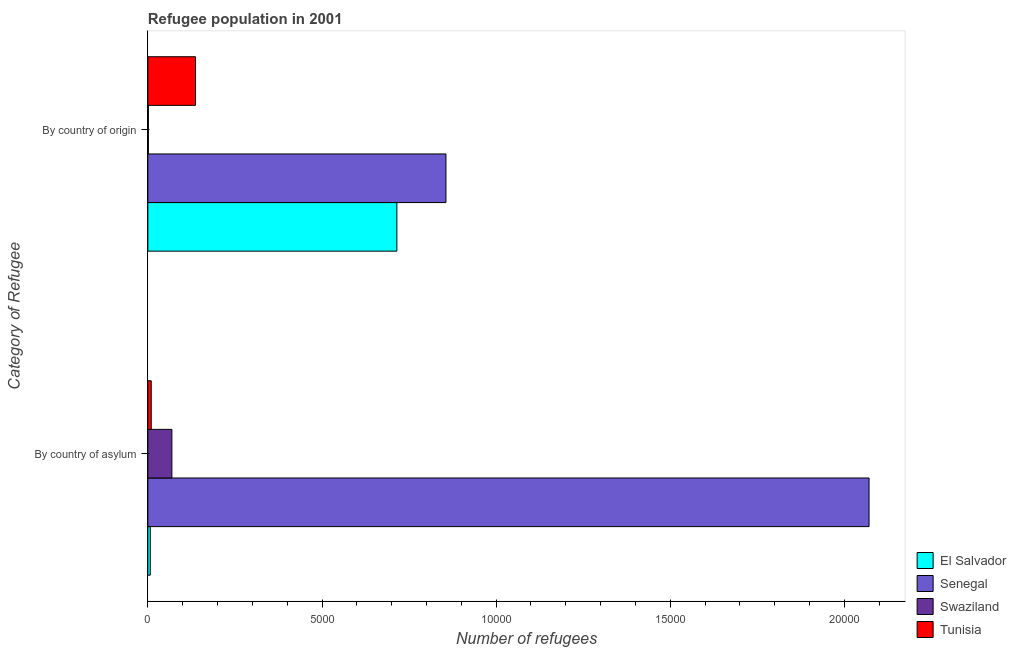How many different coloured bars are there?
Give a very brief answer. 4. Are the number of bars per tick equal to the number of legend labels?
Provide a short and direct response. Yes. Are the number of bars on each tick of the Y-axis equal?
Ensure brevity in your answer.  Yes. How many bars are there on the 1st tick from the bottom?
Provide a succinct answer. 4. What is the label of the 2nd group of bars from the top?
Your response must be concise. By country of asylum. What is the number of refugees by country of origin in El Salvador?
Keep it short and to the point. 7150. Across all countries, what is the maximum number of refugees by country of asylum?
Your answer should be compact. 2.07e+04. Across all countries, what is the minimum number of refugees by country of origin?
Your response must be concise. 15. In which country was the number of refugees by country of asylum maximum?
Your response must be concise. Senegal. In which country was the number of refugees by country of asylum minimum?
Your answer should be very brief. El Salvador. What is the total number of refugees by country of asylum in the graph?
Your answer should be very brief. 2.16e+04. What is the difference between the number of refugees by country of origin in El Salvador and that in Senegal?
Provide a succinct answer. -1409. What is the difference between the number of refugees by country of origin in El Salvador and the number of refugees by country of asylum in Senegal?
Provide a succinct answer. -1.36e+04. What is the average number of refugees by country of asylum per country?
Ensure brevity in your answer.  5390.75. What is the difference between the number of refugees by country of origin and number of refugees by country of asylum in El Salvador?
Offer a very short reply. 7081. What is the ratio of the number of refugees by country of asylum in Swaziland to that in Senegal?
Ensure brevity in your answer.  0.03. Is the number of refugees by country of asylum in El Salvador less than that in Senegal?
Make the answer very short. Yes. In how many countries, is the number of refugees by country of origin greater than the average number of refugees by country of origin taken over all countries?
Provide a short and direct response. 2. What does the 3rd bar from the top in By country of asylum represents?
Provide a succinct answer. Senegal. What does the 1st bar from the bottom in By country of asylum represents?
Provide a succinct answer. El Salvador. Are all the bars in the graph horizontal?
Ensure brevity in your answer.  Yes. What is the difference between two consecutive major ticks on the X-axis?
Offer a very short reply. 5000. Does the graph contain any zero values?
Your answer should be very brief. No. Where does the legend appear in the graph?
Your response must be concise. Bottom right. How many legend labels are there?
Give a very brief answer. 4. How are the legend labels stacked?
Give a very brief answer. Vertical. What is the title of the graph?
Ensure brevity in your answer.  Refugee population in 2001. Does "OECD members" appear as one of the legend labels in the graph?
Offer a very short reply. No. What is the label or title of the X-axis?
Provide a succinct answer. Number of refugees. What is the label or title of the Y-axis?
Give a very brief answer. Category of Refugee. What is the Number of refugees of Senegal in By country of asylum?
Offer a very short reply. 2.07e+04. What is the Number of refugees in Swaziland in By country of asylum?
Offer a very short reply. 690. What is the Number of refugees in Tunisia in By country of asylum?
Your answer should be very brief. 97. What is the Number of refugees in El Salvador in By country of origin?
Offer a very short reply. 7150. What is the Number of refugees in Senegal in By country of origin?
Your response must be concise. 8559. What is the Number of refugees of Tunisia in By country of origin?
Provide a short and direct response. 1368. Across all Category of Refugee, what is the maximum Number of refugees of El Salvador?
Offer a very short reply. 7150. Across all Category of Refugee, what is the maximum Number of refugees of Senegal?
Offer a very short reply. 2.07e+04. Across all Category of Refugee, what is the maximum Number of refugees in Swaziland?
Provide a short and direct response. 690. Across all Category of Refugee, what is the maximum Number of refugees of Tunisia?
Provide a succinct answer. 1368. Across all Category of Refugee, what is the minimum Number of refugees in El Salvador?
Your answer should be very brief. 69. Across all Category of Refugee, what is the minimum Number of refugees of Senegal?
Offer a very short reply. 8559. Across all Category of Refugee, what is the minimum Number of refugees in Tunisia?
Your answer should be very brief. 97. What is the total Number of refugees in El Salvador in the graph?
Ensure brevity in your answer.  7219. What is the total Number of refugees of Senegal in the graph?
Your answer should be compact. 2.93e+04. What is the total Number of refugees of Swaziland in the graph?
Ensure brevity in your answer.  705. What is the total Number of refugees of Tunisia in the graph?
Your response must be concise. 1465. What is the difference between the Number of refugees in El Salvador in By country of asylum and that in By country of origin?
Offer a terse response. -7081. What is the difference between the Number of refugees in Senegal in By country of asylum and that in By country of origin?
Make the answer very short. 1.21e+04. What is the difference between the Number of refugees of Swaziland in By country of asylum and that in By country of origin?
Your answer should be compact. 675. What is the difference between the Number of refugees in Tunisia in By country of asylum and that in By country of origin?
Provide a succinct answer. -1271. What is the difference between the Number of refugees of El Salvador in By country of asylum and the Number of refugees of Senegal in By country of origin?
Provide a short and direct response. -8490. What is the difference between the Number of refugees of El Salvador in By country of asylum and the Number of refugees of Swaziland in By country of origin?
Provide a short and direct response. 54. What is the difference between the Number of refugees of El Salvador in By country of asylum and the Number of refugees of Tunisia in By country of origin?
Keep it short and to the point. -1299. What is the difference between the Number of refugees in Senegal in By country of asylum and the Number of refugees in Swaziland in By country of origin?
Your answer should be very brief. 2.07e+04. What is the difference between the Number of refugees of Senegal in By country of asylum and the Number of refugees of Tunisia in By country of origin?
Provide a succinct answer. 1.93e+04. What is the difference between the Number of refugees in Swaziland in By country of asylum and the Number of refugees in Tunisia in By country of origin?
Ensure brevity in your answer.  -678. What is the average Number of refugees in El Salvador per Category of Refugee?
Offer a very short reply. 3609.5. What is the average Number of refugees in Senegal per Category of Refugee?
Make the answer very short. 1.46e+04. What is the average Number of refugees in Swaziland per Category of Refugee?
Offer a terse response. 352.5. What is the average Number of refugees in Tunisia per Category of Refugee?
Your answer should be very brief. 732.5. What is the difference between the Number of refugees in El Salvador and Number of refugees in Senegal in By country of asylum?
Give a very brief answer. -2.06e+04. What is the difference between the Number of refugees in El Salvador and Number of refugees in Swaziland in By country of asylum?
Your answer should be very brief. -621. What is the difference between the Number of refugees of Senegal and Number of refugees of Swaziland in By country of asylum?
Offer a terse response. 2.00e+04. What is the difference between the Number of refugees in Senegal and Number of refugees in Tunisia in By country of asylum?
Your answer should be compact. 2.06e+04. What is the difference between the Number of refugees of Swaziland and Number of refugees of Tunisia in By country of asylum?
Give a very brief answer. 593. What is the difference between the Number of refugees of El Salvador and Number of refugees of Senegal in By country of origin?
Your response must be concise. -1409. What is the difference between the Number of refugees in El Salvador and Number of refugees in Swaziland in By country of origin?
Give a very brief answer. 7135. What is the difference between the Number of refugees of El Salvador and Number of refugees of Tunisia in By country of origin?
Your answer should be compact. 5782. What is the difference between the Number of refugees of Senegal and Number of refugees of Swaziland in By country of origin?
Your answer should be compact. 8544. What is the difference between the Number of refugees in Senegal and Number of refugees in Tunisia in By country of origin?
Offer a very short reply. 7191. What is the difference between the Number of refugees of Swaziland and Number of refugees of Tunisia in By country of origin?
Keep it short and to the point. -1353. What is the ratio of the Number of refugees in El Salvador in By country of asylum to that in By country of origin?
Make the answer very short. 0.01. What is the ratio of the Number of refugees of Senegal in By country of asylum to that in By country of origin?
Your answer should be compact. 2.42. What is the ratio of the Number of refugees of Swaziland in By country of asylum to that in By country of origin?
Provide a succinct answer. 46. What is the ratio of the Number of refugees in Tunisia in By country of asylum to that in By country of origin?
Keep it short and to the point. 0.07. What is the difference between the highest and the second highest Number of refugees in El Salvador?
Offer a terse response. 7081. What is the difference between the highest and the second highest Number of refugees in Senegal?
Your answer should be very brief. 1.21e+04. What is the difference between the highest and the second highest Number of refugees in Swaziland?
Keep it short and to the point. 675. What is the difference between the highest and the second highest Number of refugees in Tunisia?
Your answer should be compact. 1271. What is the difference between the highest and the lowest Number of refugees of El Salvador?
Make the answer very short. 7081. What is the difference between the highest and the lowest Number of refugees of Senegal?
Your answer should be compact. 1.21e+04. What is the difference between the highest and the lowest Number of refugees of Swaziland?
Offer a very short reply. 675. What is the difference between the highest and the lowest Number of refugees of Tunisia?
Your answer should be very brief. 1271. 